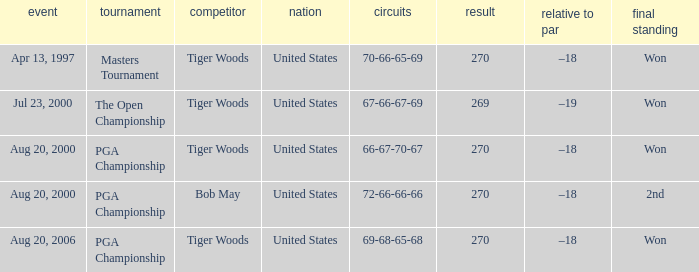Would you mind parsing the complete table? {'header': ['event', 'tournament', 'competitor', 'nation', 'circuits', 'result', 'relative to par', 'final standing'], 'rows': [['Apr 13, 1997', 'Masters Tournament', 'Tiger Woods', 'United States', '70-66-65-69', '270', '–18', 'Won'], ['Jul 23, 2000', 'The Open Championship', 'Tiger Woods', 'United States', '67-66-67-69', '269', '–19', 'Won'], ['Aug 20, 2000', 'PGA Championship', 'Tiger Woods', 'United States', '66-67-70-67', '270', '–18', 'Won'], ['Aug 20, 2000', 'PGA Championship', 'Bob May', 'United States', '72-66-66-66', '270', '–18', '2nd'], ['Aug 20, 2006', 'PGA Championship', 'Tiger Woods', 'United States', '69-68-65-68', '270', '–18', 'Won']]} What country hosts the tournament the open championship? United States. 